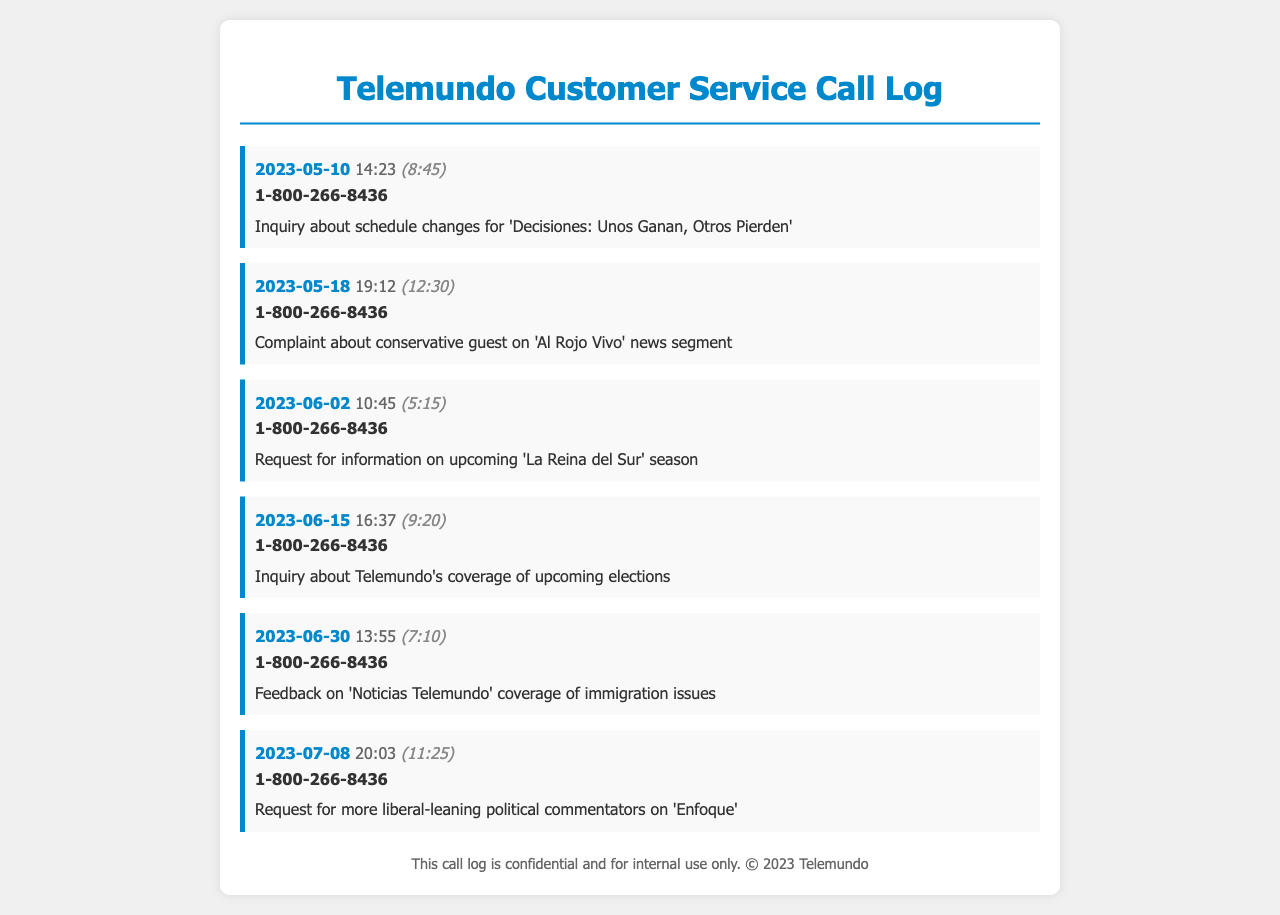what is the date of the earliest call? The earliest call in the log is dated May 10, 2023.
Answer: May 10, 2023 how long was the call on May 18, 2023? The duration of the call on May 18, 2023, was 12 minutes and 30 seconds.
Answer: 12:30 which program was inquired about on June 2, 2023? The call on June 2, 2023, was regarding 'La Reina del Sur' season.
Answer: 'La Reina del Sur' what issue was addressed in the call on June 30, 2023? The call on June 30, 2023, provided feedback on immigration issues coverage.
Answer: immigration issues how many calls were made regarding political content? There are three calls that pertain to political content in the log.
Answer: 3 what time was the call made on June 15, 2023? The call on June 15, 2023, was made at 16:37.
Answer: 16:37 who was contacted for customer service inquiries? The customer service number contacted was 1-800-266-8436.
Answer: 1-800-266-8436 which month had the highest call duration? The month of June had the longest duration for the calls.
Answer: June 